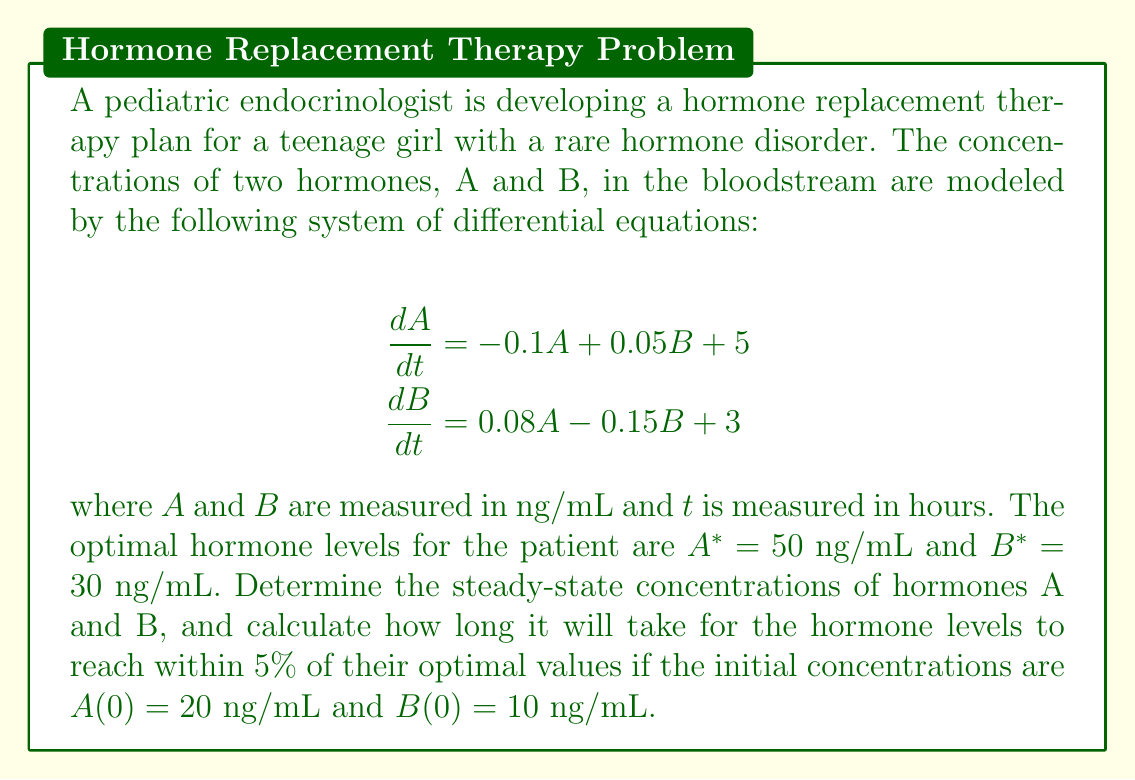Provide a solution to this math problem. To solve this problem, we'll follow these steps:

1. Find the steady-state concentrations
2. Determine the eigenvalues of the system
3. Calculate the time required to reach within 5% of optimal values

Step 1: Steady-state concentrations

At steady state, $\frac{dA}{dt} = \frac{dB}{dt} = 0$. So we have:

$$\begin{align}
0 &= -0.1A + 0.05B + 5 \\
0 &= 0.08A - 0.15B + 3
\end{align}$$

Solving this system of equations:

$$\begin{align}
A &= 50 \text{ ng/mL} \\
B &= 30 \text{ ng/mL}
\end{align}$$

Coincidentally, these are exactly the optimal hormone levels for the patient.

Step 2: Eigenvalues of the system

The system matrix is:

$$A = \begin{bmatrix}
-0.1 & 0.05 \\
0.08 & -0.15
\end{bmatrix}$$

The characteristic equation is:

$$\det(A - \lambda I) = \begin{vmatrix}
-0.1 - \lambda & 0.05 \\
0.08 & -0.15 - \lambda
\end{vmatrix} = \lambda^2 + 0.25\lambda + 0.011 = 0$$

Solving this equation, we get:

$$\lambda_1 \approx -0.2287, \lambda_2 \approx -0.0213$$

Step 3: Time to reach within 5% of optimal values

The general solution for this system is of the form:

$$\begin{bmatrix}
A(t) - A^* \\
B(t) - B^*
\end{bmatrix} = c_1e^{\lambda_1t}\mathbf{v_1} + c_2e^{\lambda_2t}\mathbf{v_2}$$

where $\mathbf{v_1}$ and $\mathbf{v_2}$ are the eigenvectors corresponding to $\lambda_1$ and $\lambda_2$.

The slowest decaying term is associated with $\lambda_2$, so we'll focus on that. We want to find $t$ such that:

$$e^{\lambda_2t} = 0.05$$

Taking the natural log of both sides:

$$\lambda_2t = \ln(0.05)$$

$$t = \frac{\ln(0.05)}{\lambda_2} \approx \frac{-2.9957}{-0.0213} \approx 140.6 \text{ hours}$$

Therefore, it will take approximately 140.6 hours (about 5.9 days) for the hormone levels to reach within 5% of their optimal values.
Answer: The steady-state concentrations are $A = 50$ ng/mL and $B = 30$ ng/mL. It will take approximately 140.6 hours for the hormone levels to reach within 5% of their optimal values. 